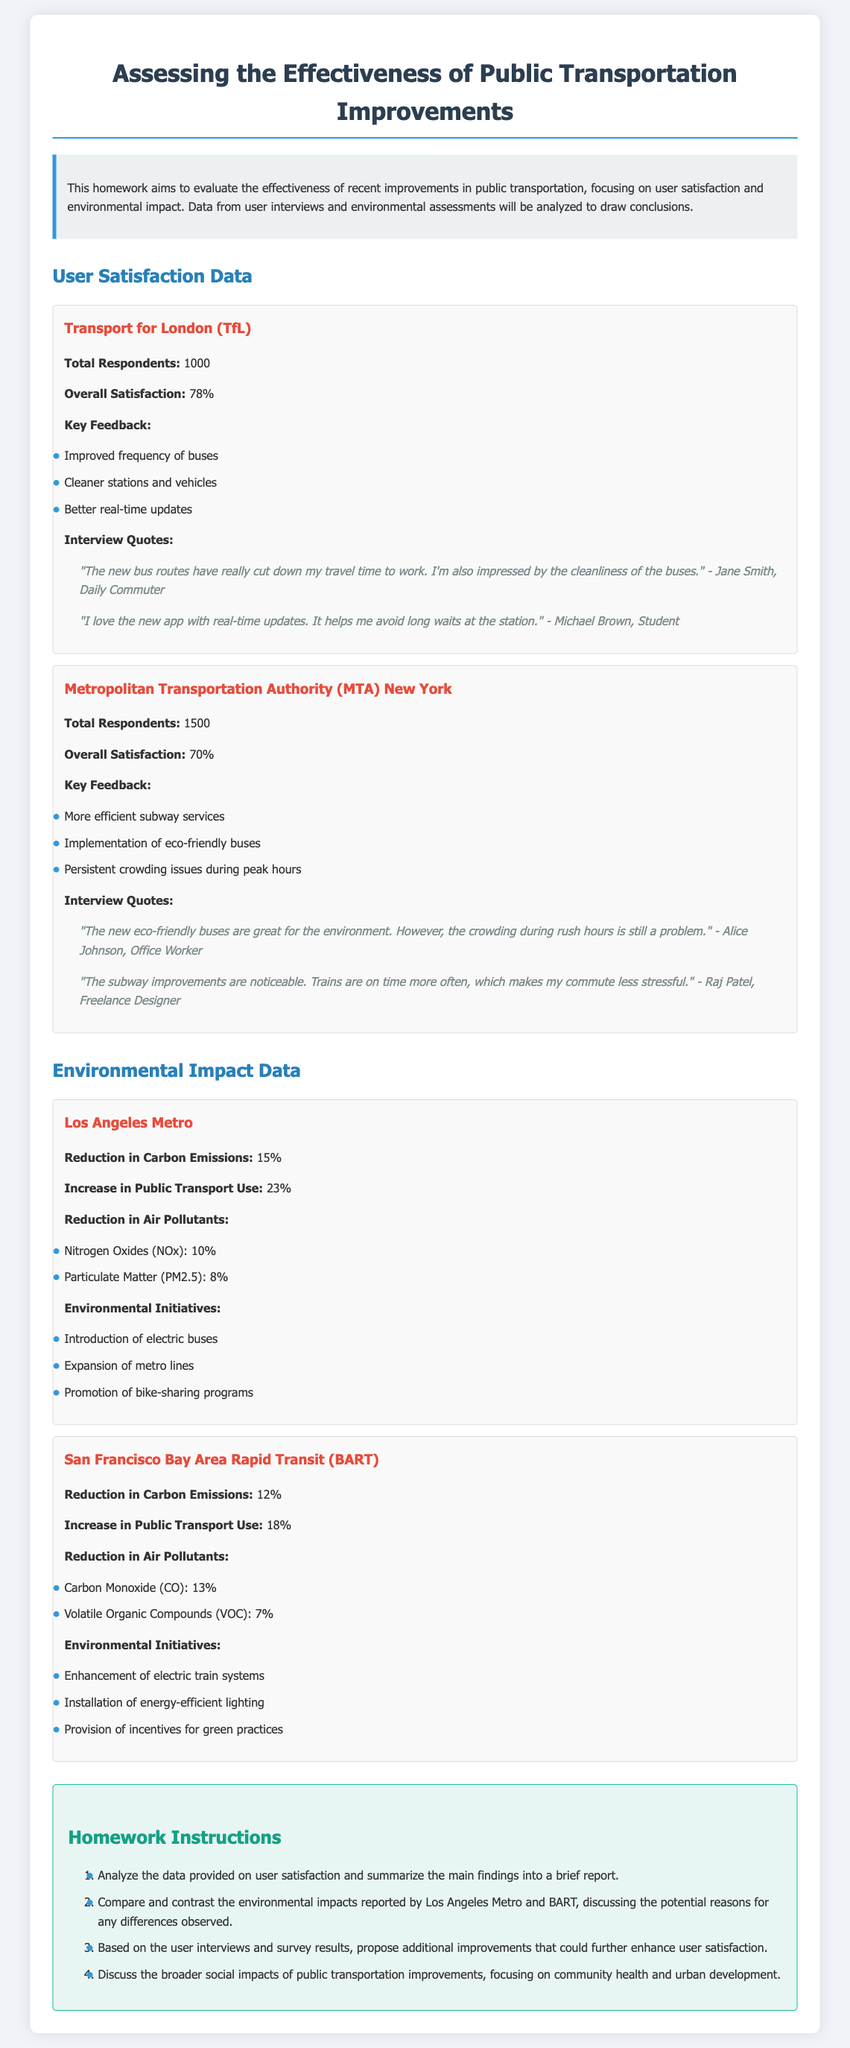What is the overall satisfaction percentage for TfL? The overall satisfaction percentage is 78% for TfL as stated in the user satisfaction data.
Answer: 78% What is the reduction in carbon emissions reported by Los Angeles Metro? The reduction in carbon emissions for Los Angeles Metro is stated as 15% in the environmental impact data.
Answer: 15% How many total respondents were surveyed for the MTA? The total respondents for the MTA are 1500, as mentioned in the user satisfaction data.
Answer: 1500 What is one of the key feedback points from TfL users? One of the key feedback points from TfL users is "Improved frequency of buses."
Answer: Improved frequency of buses Which air pollutant saw a 10% reduction due to Los Angeles Metro initiatives? The air pollutant with a 10% reduction due to Los Angeles Metro initiatives is Nitrogen Oxides (NOx).
Answer: Nitrogen Oxides (NOx) What is the overall satisfaction percentage for MTA? The overall satisfaction percentage for MTA is 70%, as shown in the user satisfaction data.
Answer: 70% Discussing user satisfaction, what improvement do users want further? Users suggested the implementation of better real-time updates as a potential additional improvement to enhance satisfaction.
Answer: Better real-time updates What initiative has been introduced by Los Angeles Metro to reduce carbon emissions? Los Angeles Metro introduced electric buses as one of the initiatives to reduce carbon emissions.
Answer: Electric buses What was the percentage increase in public transport use for BART? The increase in public transport use for BART is 18%, as indicated in the environmental impact data.
Answer: 18% 